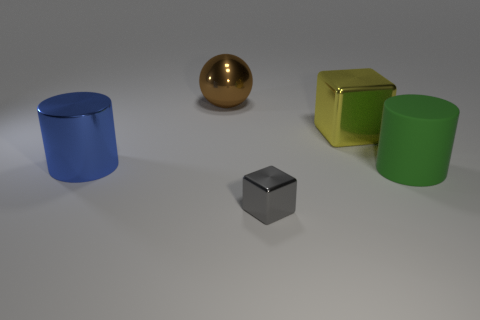Add 3 cubes. How many objects exist? 8 Subtract all spheres. How many objects are left? 4 Add 2 blue metallic objects. How many blue metallic objects are left? 3 Add 1 big brown rubber cylinders. How many big brown rubber cylinders exist? 1 Subtract 1 yellow cubes. How many objects are left? 4 Subtract all big green matte cylinders. Subtract all large yellow blocks. How many objects are left? 3 